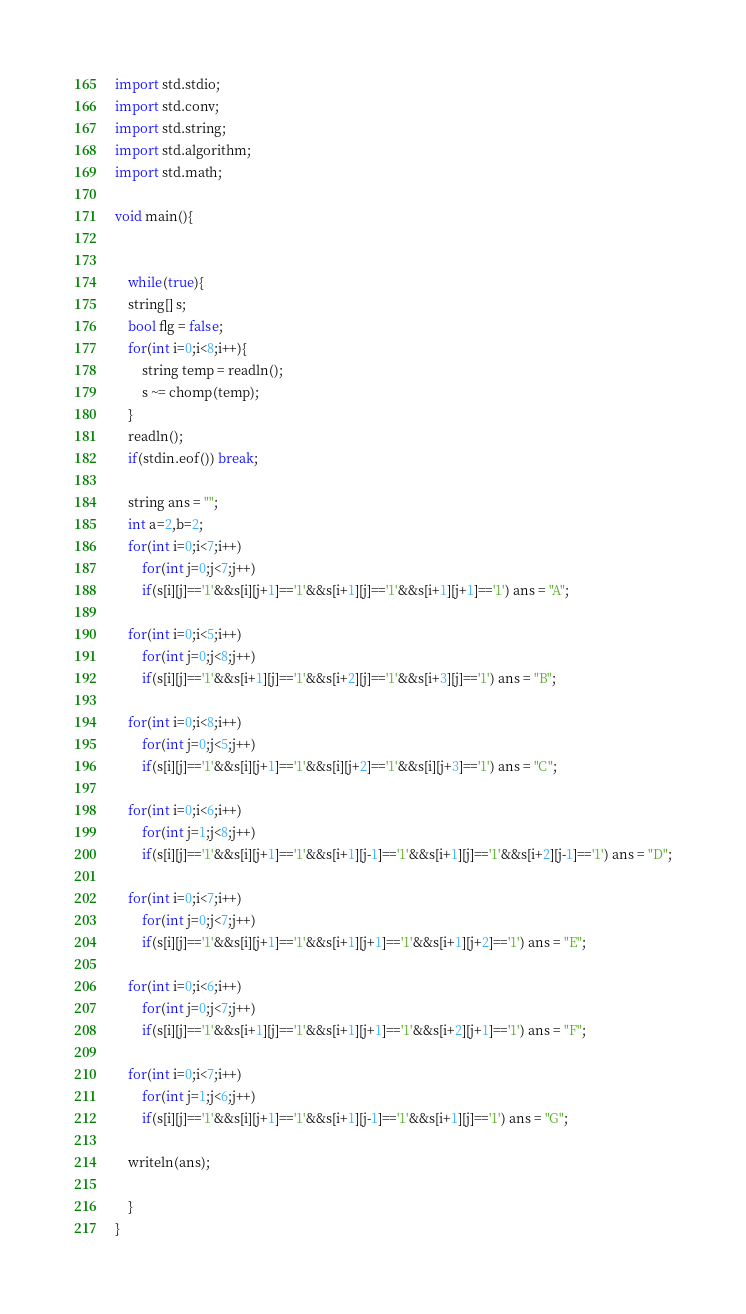Convert code to text. <code><loc_0><loc_0><loc_500><loc_500><_D_>import std.stdio;
import std.conv;
import std.string;
import std.algorithm;
import std.math;

void main(){


    while(true){
	string[] s;
	bool flg = false;
	for(int i=0;i<8;i++){
	    string temp = readln();
	    s ~= chomp(temp);
	}
	readln();
	if(stdin.eof()) break;

	string ans = "";
	int a=2,b=2;
	for(int i=0;i<7;i++)
	    for(int j=0;j<7;j++)
		if(s[i][j]=='1'&&s[i][j+1]=='1'&&s[i+1][j]=='1'&&s[i+1][j+1]=='1') ans = "A";

	for(int i=0;i<5;i++)
	    for(int j=0;j<8;j++)
		if(s[i][j]=='1'&&s[i+1][j]=='1'&&s[i+2][j]=='1'&&s[i+3][j]=='1') ans = "B";

	for(int i=0;i<8;i++)
	    for(int j=0;j<5;j++)
		if(s[i][j]=='1'&&s[i][j+1]=='1'&&s[i][j+2]=='1'&&s[i][j+3]=='1') ans = "C";

	for(int i=0;i<6;i++)
	    for(int j=1;j<8;j++)
		if(s[i][j]=='1'&&s[i][j+1]=='1'&&s[i+1][j-1]=='1'&&s[i+1][j]=='1'&&s[i+2][j-1]=='1') ans = "D";

	for(int i=0;i<7;i++)
	    for(int j=0;j<7;j++)
		if(s[i][j]=='1'&&s[i][j+1]=='1'&&s[i+1][j+1]=='1'&&s[i+1][j+2]=='1') ans = "E";

	for(int i=0;i<6;i++)
	    for(int j=0;j<7;j++)
		if(s[i][j]=='1'&&s[i+1][j]=='1'&&s[i+1][j+1]=='1'&&s[i+2][j+1]=='1') ans = "F";

	for(int i=0;i<7;i++)
	    for(int j=1;j<6;j++)
		if(s[i][j]=='1'&&s[i][j+1]=='1'&&s[i+1][j-1]=='1'&&s[i+1][j]=='1') ans = "G";

	writeln(ans);

    }
}</code> 